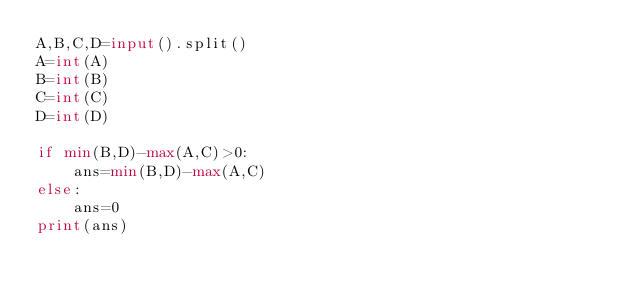Convert code to text. <code><loc_0><loc_0><loc_500><loc_500><_Python_>A,B,C,D=input().split()
A=int(A)
B=int(B)
C=int(C)
D=int(D)

if min(B,D)-max(A,C)>0:
    ans=min(B,D)-max(A,C)
else:
    ans=0
print(ans)</code> 